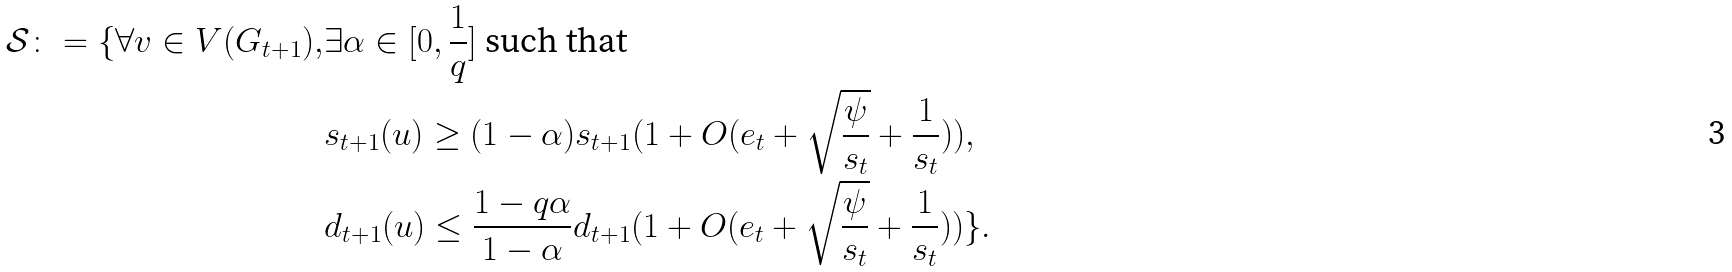Convert formula to latex. <formula><loc_0><loc_0><loc_500><loc_500>\mathcal { S } \colon = \{ \forall v \in V ( G _ { t + 1 } ) , & \exists \alpha \in [ 0 , \frac { 1 } { q } ] \text { such that } \\ & s _ { t + 1 } ( u ) \geq ( 1 - \alpha ) s _ { t + 1 } ( 1 + O ( e _ { t } + \sqrt { \frac { \psi } { s _ { t } } } + \frac { 1 } { s _ { t } } ) ) , \\ & d _ { t + 1 } ( u ) \leq \frac { 1 - q \alpha } { 1 - \alpha } d _ { t + 1 } ( 1 + O ( e _ { t } + \sqrt { \frac { \psi } { s _ { t } } } + \frac { 1 } { s _ { t } } ) ) \} .</formula> 